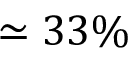<formula> <loc_0><loc_0><loc_500><loc_500>\simeq 3 3 \%</formula> 